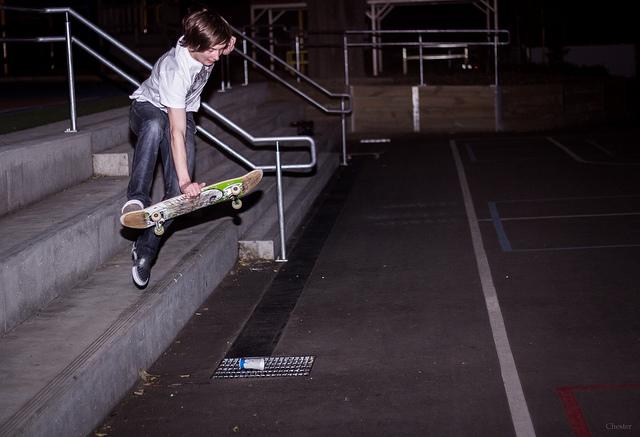The boy can easily trip?
Short answer required. Yes. Is it day time?
Concise answer only. No. Can this Boy Trip on the grate?
Concise answer only. Yes. 